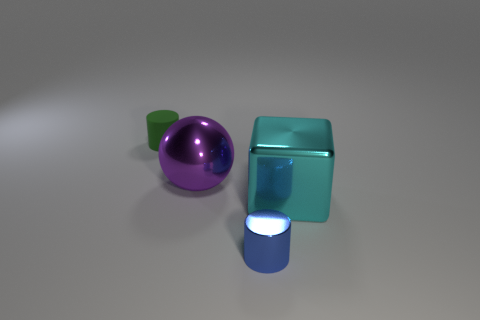Add 2 cyan metal blocks. How many objects exist? 6 Subtract all green cylinders. How many cylinders are left? 1 Subtract all blocks. How many objects are left? 3 Subtract all purple spheres. How many green cylinders are left? 1 Subtract all large purple spheres. Subtract all cyan objects. How many objects are left? 2 Add 1 big blocks. How many big blocks are left? 2 Add 4 cyan matte cylinders. How many cyan matte cylinders exist? 4 Subtract 0 purple blocks. How many objects are left? 4 Subtract 1 balls. How many balls are left? 0 Subtract all blue cylinders. Subtract all gray cubes. How many cylinders are left? 1 